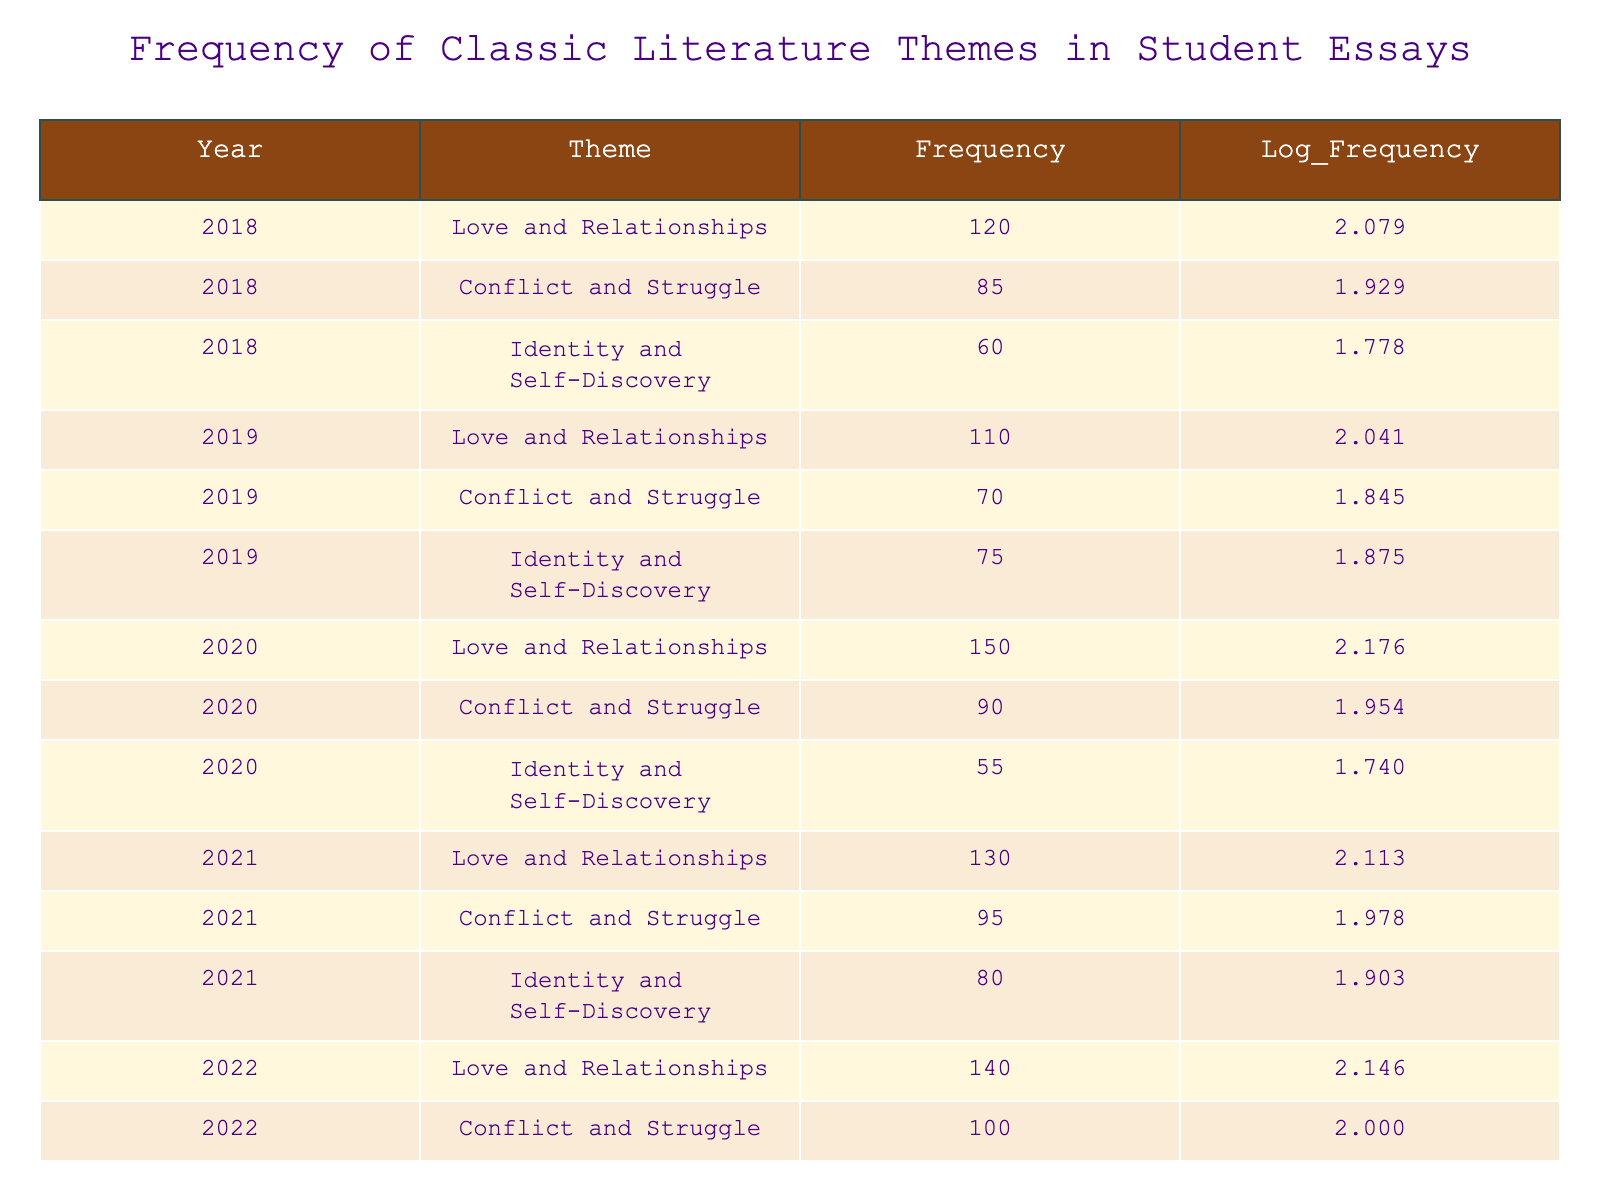What is the frequency of the theme "Love and Relationships" for the year 2020? The frequency for "Love and Relationships" in 2020 is directly recorded in the table under the corresponding year and theme. It shows a frequency value of 150.
Answer: 150 In which year did "Conflict and Struggle" have the highest frequency? By examining the frequencies of "Conflict and Struggle" for each year, we find the highest value is 100, which occurs in 2022.
Answer: 2022 What is the sum of "Identity and Self-Discovery" frequencies from 2018 to 2022? The frequencies for "Identity and Self-Discovery" for the years 2018 (60), 2019 (75), 2020 (55), 2021 (80), and 2022 (90) need to be added together: 60 + 75 + 55 + 80 + 90 = 360.
Answer: 360 Is the frequency of "Love and Relationships" in 2021 greater than in 2019? The frequency of "Love and Relationships" in 2021 is 130 and in 2019 is 110. Since 130 > 110, the statement is true.
Answer: Yes What is the average frequency of "Conflict and Struggle" across all years? To find the average, we total the frequencies: 85 (2018) + 70 (2019) + 90 (2020) + 95 (2021) + 100 (2022) = 440. Next, divide by the number of years, which is 5: 440 / 5 = 88.
Answer: 88 In which year did the frequency of "Identity and Self-Discovery" decrease compared to the previous year? By comparing the frequencies year by year: 2018 (60), 2019 (75), 2020 (55), 2021 (80), 2022 (90), we can see that the frequency decreased from 2019 (75) to 2020 (55).
Answer: 2020 What is the difference between the highest and lowest frequency of the theme "Love and Relationships" from 2018 to 2022? The highest frequency for "Love and Relationships" is 150 in 2020, and the lowest is 120 in 2018. The difference is calculated as 150 - 120 = 30.
Answer: 30 How many times did "Identity and Self-Discovery" reach frequencies above 70 across the years? Reviewing the frequencies: 2018 (60), 2019 (75), 2020 (55), 2021 (80), and 2022 (90), we find that it is above 70 in 2019, 2021, and 2022. This totals 3 instances.
Answer: 3 